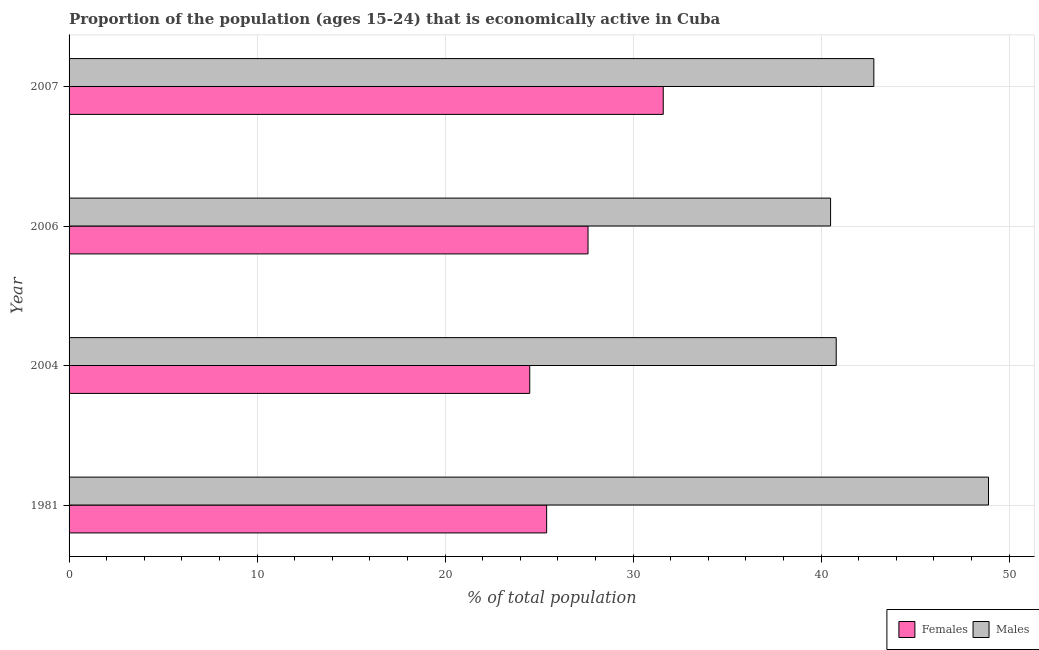How many different coloured bars are there?
Make the answer very short. 2. Are the number of bars per tick equal to the number of legend labels?
Offer a very short reply. Yes. How many bars are there on the 3rd tick from the top?
Keep it short and to the point. 2. What is the label of the 2nd group of bars from the top?
Your answer should be very brief. 2006. What is the percentage of economically active male population in 1981?
Provide a succinct answer. 48.9. Across all years, what is the maximum percentage of economically active female population?
Your response must be concise. 31.6. Across all years, what is the minimum percentage of economically active male population?
Your answer should be compact. 40.5. In which year was the percentage of economically active male population maximum?
Provide a succinct answer. 1981. In which year was the percentage of economically active male population minimum?
Your answer should be very brief. 2006. What is the total percentage of economically active male population in the graph?
Provide a short and direct response. 173. What is the difference between the percentage of economically active female population in 1981 and that in 2004?
Make the answer very short. 0.9. What is the difference between the percentage of economically active female population in 2006 and the percentage of economically active male population in 2004?
Offer a terse response. -13.2. What is the average percentage of economically active male population per year?
Your response must be concise. 43.25. In the year 1981, what is the difference between the percentage of economically active female population and percentage of economically active male population?
Provide a short and direct response. -23.5. In how many years, is the percentage of economically active male population greater than 24 %?
Offer a terse response. 4. What is the ratio of the percentage of economically active female population in 2006 to that in 2007?
Your answer should be compact. 0.87. Is the percentage of economically active male population in 1981 less than that in 2007?
Keep it short and to the point. No. What is the difference between the highest and the second highest percentage of economically active male population?
Give a very brief answer. 6.1. What is the difference between the highest and the lowest percentage of economically active female population?
Your answer should be very brief. 7.1. What does the 2nd bar from the top in 1981 represents?
Make the answer very short. Females. What does the 2nd bar from the bottom in 1981 represents?
Give a very brief answer. Males. How many years are there in the graph?
Keep it short and to the point. 4. Does the graph contain any zero values?
Provide a succinct answer. No. Does the graph contain grids?
Make the answer very short. Yes. Where does the legend appear in the graph?
Make the answer very short. Bottom right. What is the title of the graph?
Your answer should be compact. Proportion of the population (ages 15-24) that is economically active in Cuba. Does "Exports of goods" appear as one of the legend labels in the graph?
Keep it short and to the point. No. What is the label or title of the X-axis?
Offer a very short reply. % of total population. What is the label or title of the Y-axis?
Provide a short and direct response. Year. What is the % of total population of Females in 1981?
Provide a succinct answer. 25.4. What is the % of total population of Males in 1981?
Keep it short and to the point. 48.9. What is the % of total population in Females in 2004?
Give a very brief answer. 24.5. What is the % of total population in Males in 2004?
Your answer should be compact. 40.8. What is the % of total population of Females in 2006?
Provide a succinct answer. 27.6. What is the % of total population of Males in 2006?
Your response must be concise. 40.5. What is the % of total population in Females in 2007?
Offer a very short reply. 31.6. What is the % of total population of Males in 2007?
Offer a terse response. 42.8. Across all years, what is the maximum % of total population of Females?
Your answer should be compact. 31.6. Across all years, what is the maximum % of total population of Males?
Your answer should be compact. 48.9. Across all years, what is the minimum % of total population of Females?
Ensure brevity in your answer.  24.5. Across all years, what is the minimum % of total population of Males?
Provide a succinct answer. 40.5. What is the total % of total population in Females in the graph?
Offer a very short reply. 109.1. What is the total % of total population of Males in the graph?
Ensure brevity in your answer.  173. What is the difference between the % of total population of Females in 1981 and that in 2007?
Make the answer very short. -6.2. What is the difference between the % of total population in Males in 2004 and that in 2006?
Ensure brevity in your answer.  0.3. What is the difference between the % of total population of Males in 2004 and that in 2007?
Ensure brevity in your answer.  -2. What is the difference between the % of total population in Females in 1981 and the % of total population in Males in 2004?
Ensure brevity in your answer.  -15.4. What is the difference between the % of total population of Females in 1981 and the % of total population of Males in 2006?
Your response must be concise. -15.1. What is the difference between the % of total population in Females in 1981 and the % of total population in Males in 2007?
Ensure brevity in your answer.  -17.4. What is the difference between the % of total population of Females in 2004 and the % of total population of Males in 2006?
Your answer should be compact. -16. What is the difference between the % of total population of Females in 2004 and the % of total population of Males in 2007?
Offer a terse response. -18.3. What is the difference between the % of total population of Females in 2006 and the % of total population of Males in 2007?
Offer a very short reply. -15.2. What is the average % of total population in Females per year?
Your answer should be very brief. 27.27. What is the average % of total population in Males per year?
Offer a very short reply. 43.25. In the year 1981, what is the difference between the % of total population of Females and % of total population of Males?
Your response must be concise. -23.5. In the year 2004, what is the difference between the % of total population in Females and % of total population in Males?
Your answer should be very brief. -16.3. In the year 2007, what is the difference between the % of total population in Females and % of total population in Males?
Offer a terse response. -11.2. What is the ratio of the % of total population in Females in 1981 to that in 2004?
Provide a succinct answer. 1.04. What is the ratio of the % of total population in Males in 1981 to that in 2004?
Your answer should be compact. 1.2. What is the ratio of the % of total population in Females in 1981 to that in 2006?
Make the answer very short. 0.92. What is the ratio of the % of total population of Males in 1981 to that in 2006?
Offer a very short reply. 1.21. What is the ratio of the % of total population of Females in 1981 to that in 2007?
Keep it short and to the point. 0.8. What is the ratio of the % of total population in Males in 1981 to that in 2007?
Make the answer very short. 1.14. What is the ratio of the % of total population of Females in 2004 to that in 2006?
Ensure brevity in your answer.  0.89. What is the ratio of the % of total population in Males in 2004 to that in 2006?
Provide a short and direct response. 1.01. What is the ratio of the % of total population of Females in 2004 to that in 2007?
Offer a terse response. 0.78. What is the ratio of the % of total population of Males in 2004 to that in 2007?
Offer a terse response. 0.95. What is the ratio of the % of total population of Females in 2006 to that in 2007?
Keep it short and to the point. 0.87. What is the ratio of the % of total population in Males in 2006 to that in 2007?
Offer a very short reply. 0.95. What is the difference between the highest and the second highest % of total population of Females?
Give a very brief answer. 4. What is the difference between the highest and the second highest % of total population in Males?
Give a very brief answer. 6.1. What is the difference between the highest and the lowest % of total population in Females?
Ensure brevity in your answer.  7.1. What is the difference between the highest and the lowest % of total population of Males?
Your response must be concise. 8.4. 